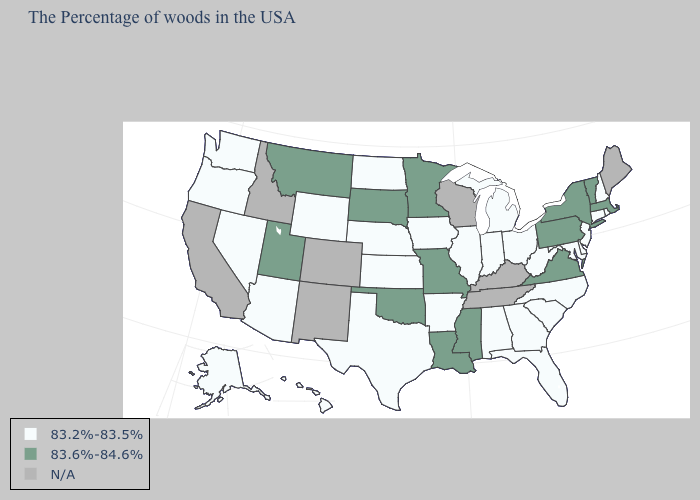Which states have the lowest value in the USA?
Answer briefly. Rhode Island, New Hampshire, Connecticut, New Jersey, Delaware, Maryland, North Carolina, South Carolina, West Virginia, Ohio, Florida, Georgia, Michigan, Indiana, Alabama, Illinois, Arkansas, Iowa, Kansas, Nebraska, Texas, North Dakota, Wyoming, Arizona, Nevada, Washington, Oregon, Alaska, Hawaii. What is the highest value in the MidWest ?
Write a very short answer. 83.6%-84.6%. How many symbols are there in the legend?
Write a very short answer. 3. What is the value of Kansas?
Concise answer only. 83.2%-83.5%. What is the lowest value in the USA?
Concise answer only. 83.2%-83.5%. What is the lowest value in the South?
Answer briefly. 83.2%-83.5%. Among the states that border Massachusetts , which have the lowest value?
Write a very short answer. Rhode Island, New Hampshire, Connecticut. Does Massachusetts have the highest value in the Northeast?
Give a very brief answer. Yes. What is the value of Vermont?
Give a very brief answer. 83.6%-84.6%. Which states hav the highest value in the South?
Give a very brief answer. Virginia, Mississippi, Louisiana, Oklahoma. Name the states that have a value in the range 83.2%-83.5%?
Quick response, please. Rhode Island, New Hampshire, Connecticut, New Jersey, Delaware, Maryland, North Carolina, South Carolina, West Virginia, Ohio, Florida, Georgia, Michigan, Indiana, Alabama, Illinois, Arkansas, Iowa, Kansas, Nebraska, Texas, North Dakota, Wyoming, Arizona, Nevada, Washington, Oregon, Alaska, Hawaii. Which states hav the highest value in the West?
Short answer required. Utah, Montana. What is the value of Iowa?
Short answer required. 83.2%-83.5%. What is the value of Idaho?
Quick response, please. N/A. 